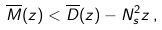Convert formula to latex. <formula><loc_0><loc_0><loc_500><loc_500>\overline { M } ( z ) < \overline { D } ( z ) - N _ { s } ^ { 2 } z \, ,</formula> 